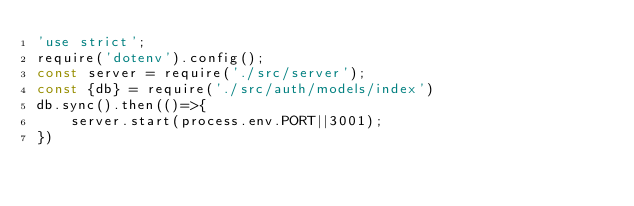Convert code to text. <code><loc_0><loc_0><loc_500><loc_500><_JavaScript_>'use strict';
require('dotenv').config();
const server = require('./src/server');
const {db} = require('./src/auth/models/index')
db.sync().then(()=>{
    server.start(process.env.PORT||3001);
})</code> 